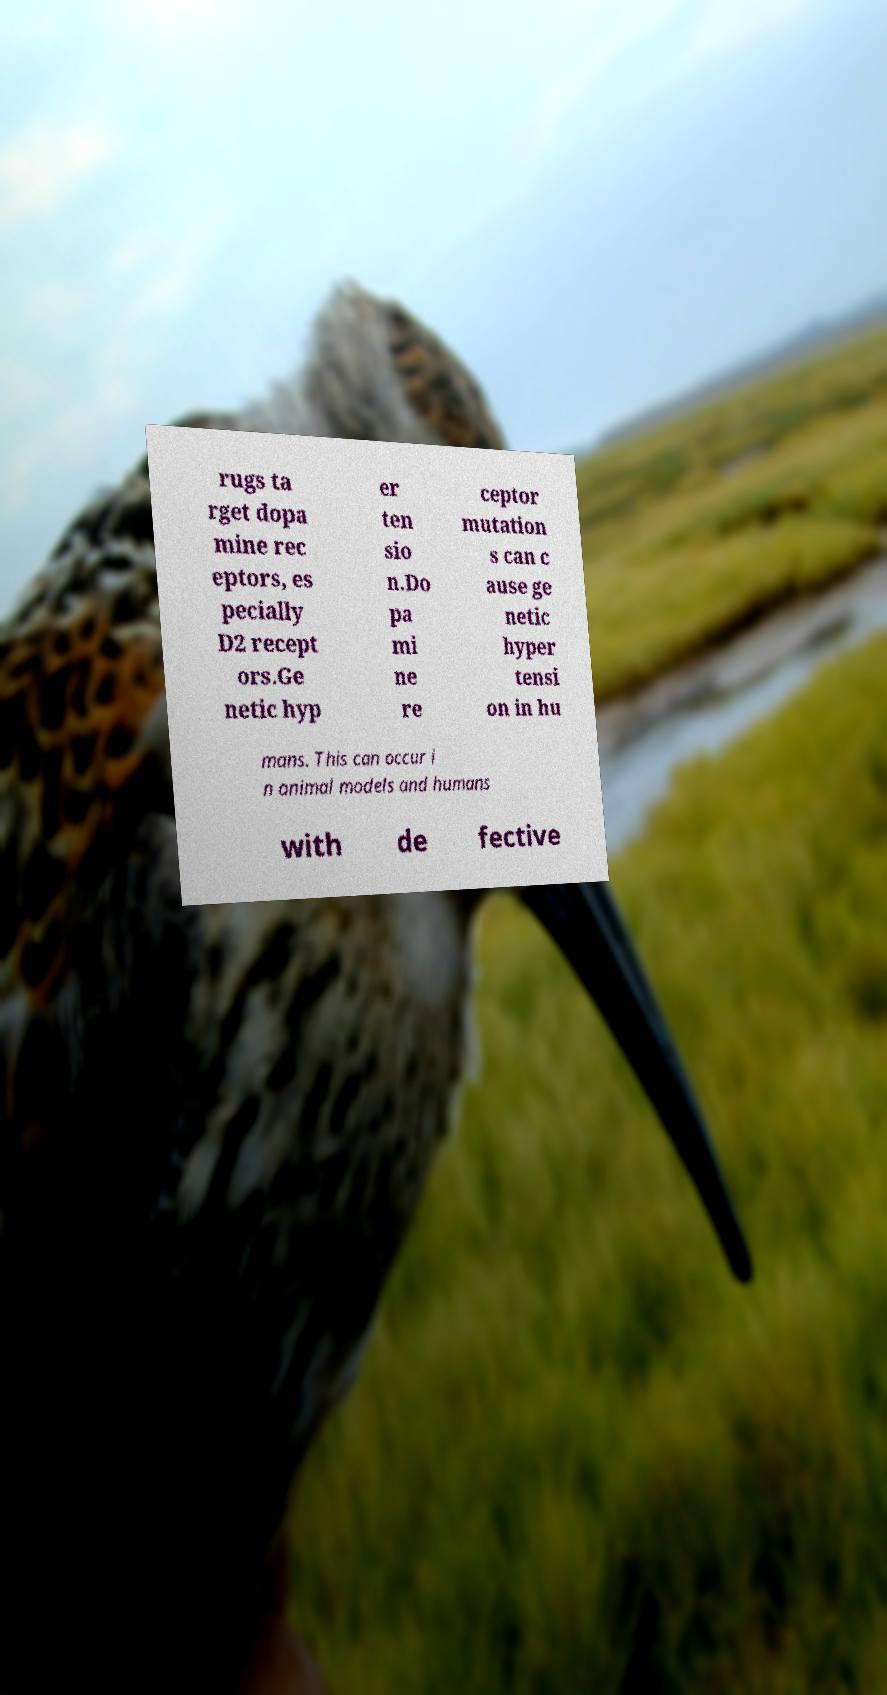Can you read and provide the text displayed in the image?This photo seems to have some interesting text. Can you extract and type it out for me? rugs ta rget dopa mine rec eptors, es pecially D2 recept ors.Ge netic hyp er ten sio n.Do pa mi ne re ceptor mutation s can c ause ge netic hyper tensi on in hu mans. This can occur i n animal models and humans with de fective 